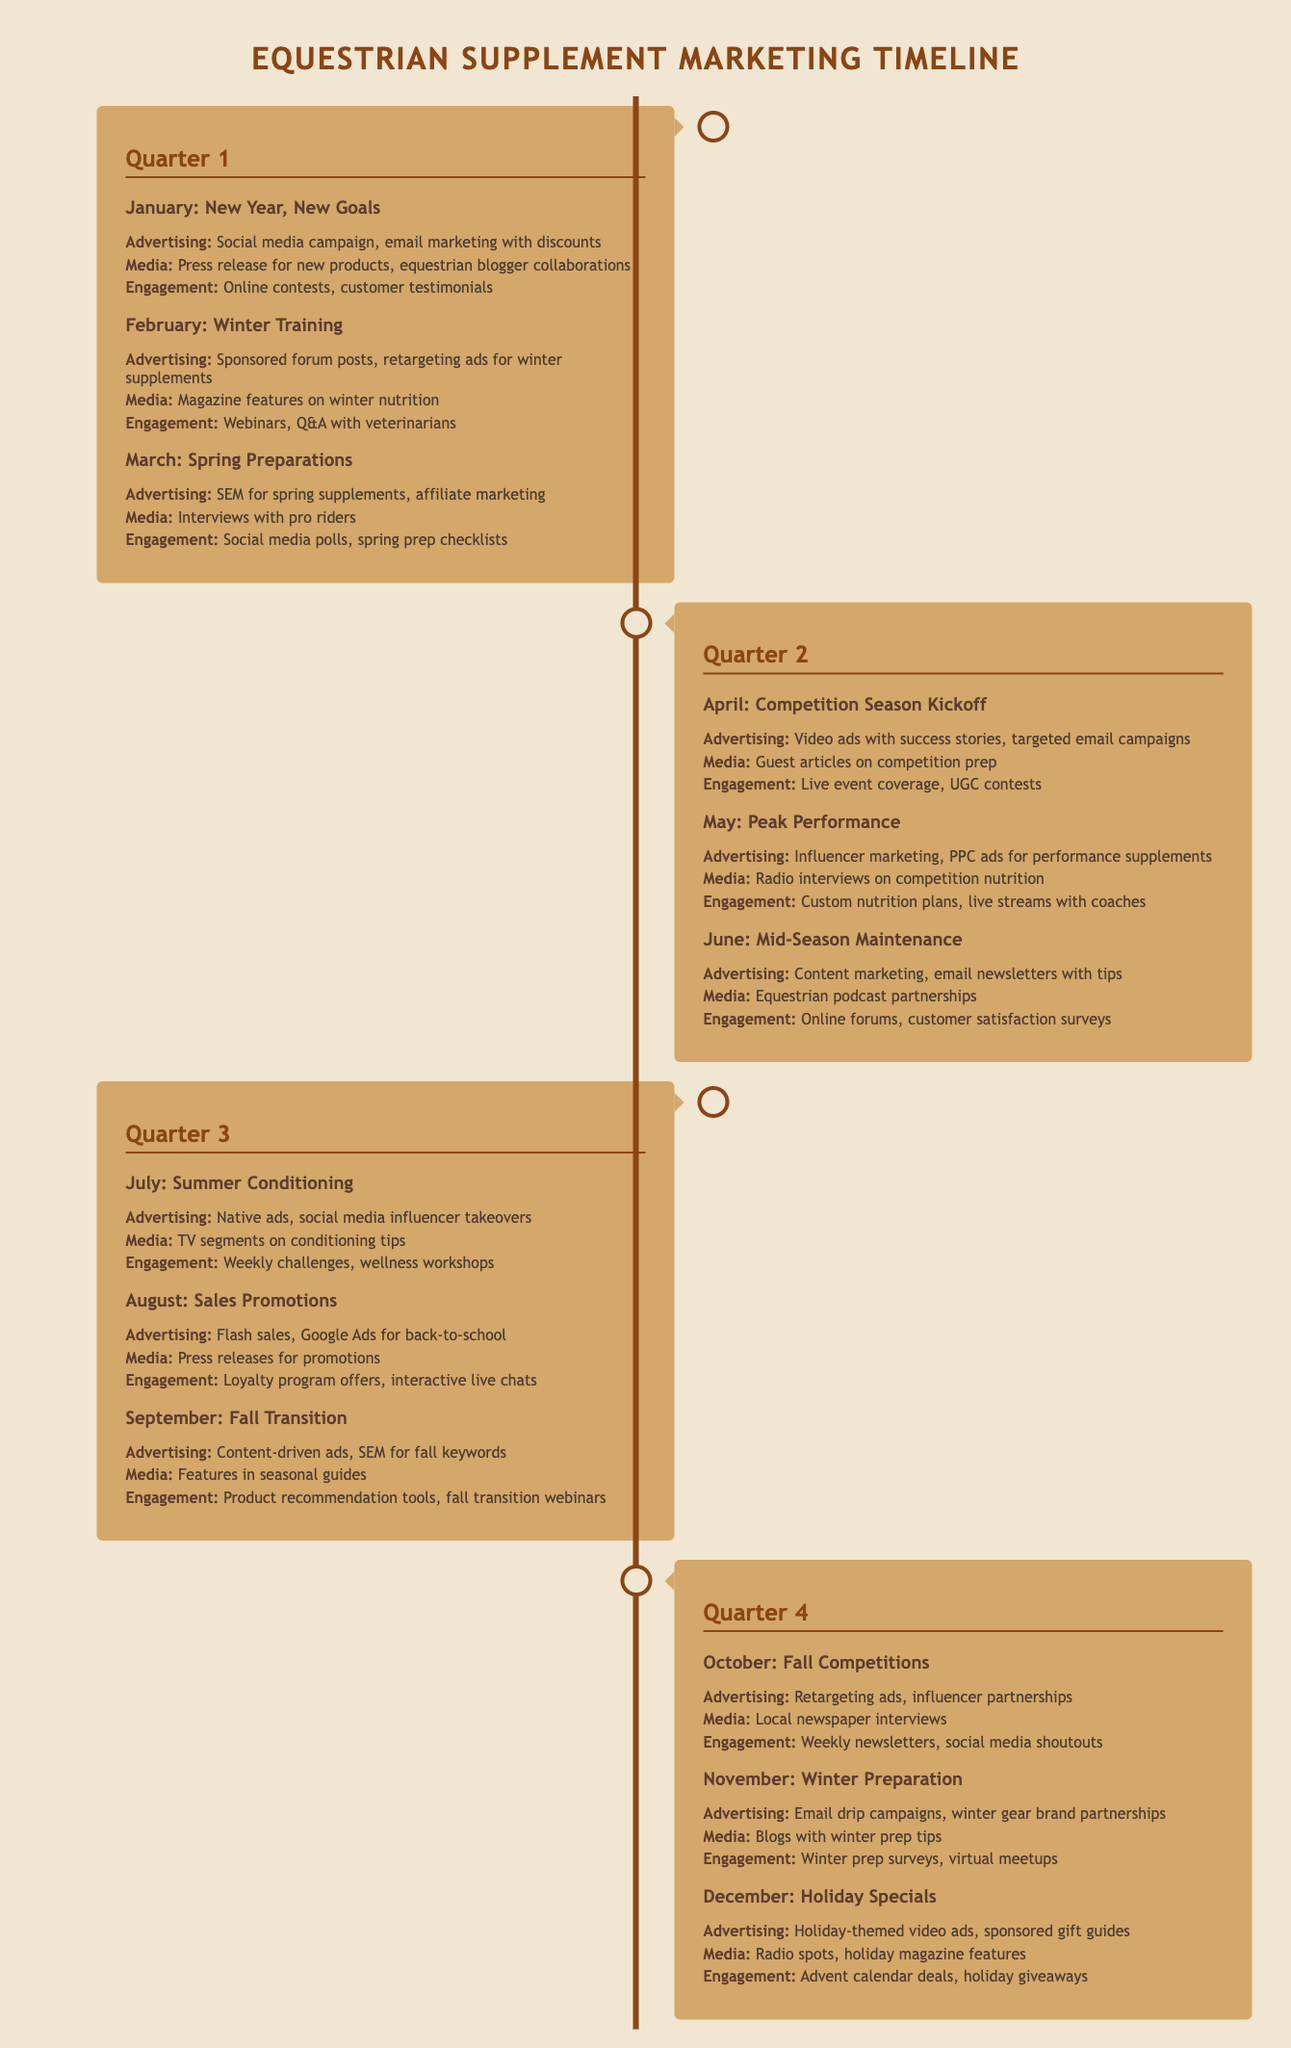What is the primary advertising focus in January? The primary advertising focus in January is a social media campaign and email marketing with discounts.
Answer: Social media campaign, email marketing with discounts Which month features influencer marketing as an advertising strategy? Influencer marketing is highlighted in May as part of the advertising strategy for peak performance.
Answer: May What media engagement is planned for October? In October, the media engagement planned includes local newspaper interviews.
Answer: Local newspaper interviews How many quarters are covered in the timeline? The timeline covers a total of four quarters.
Answer: Four What is the engagement strategy for November? In November, the engagement strategy includes winter prep surveys and virtual meetups.
Answer: Winter prep surveys, virtual meetups What type of ads are scheduled for August? The scheduled ads for August include flash sales and Google Ads for back-to-school.
Answer: Flash sales, Google Ads for back-to-school Which month includes success story video ads? Success story video ads are scheduled for April.
Answer: April What is the main theme of the March advertising strategy? The main theme of March's advertising strategy is SEM for spring supplements.
Answer: SEM for spring supplements 